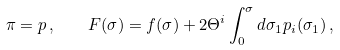<formula> <loc_0><loc_0><loc_500><loc_500>\pi = p \, , \quad F ( \sigma ) = f ( \sigma ) + 2 \Theta ^ { i } \int ^ { \sigma } _ { 0 } d \sigma _ { 1 } p _ { i } ( \sigma _ { 1 } ) \, ,</formula> 